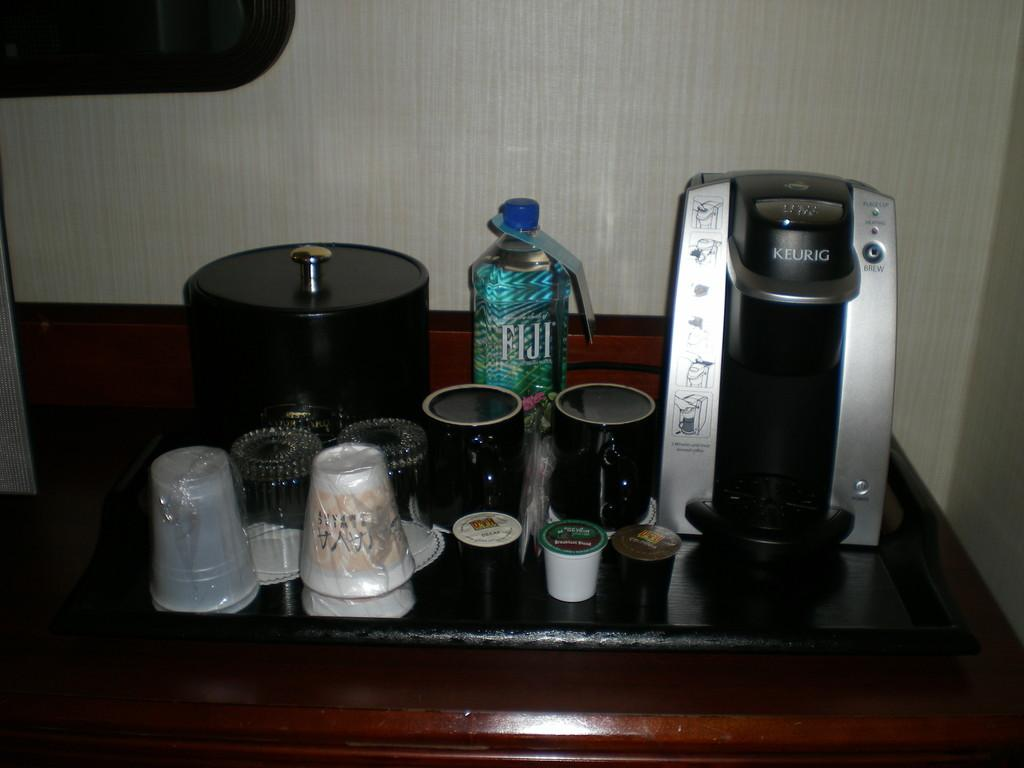Provide a one-sentence caption for the provided image. A Keurig coffee maker sits next to mugs and a bottle of Fiji water. 